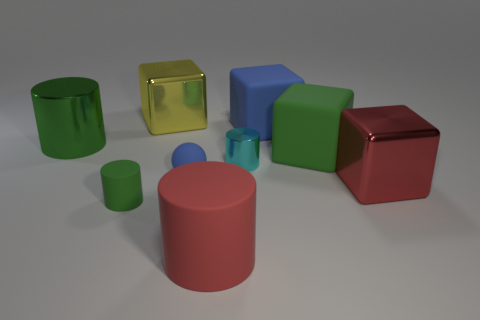Is there anything else that is the same color as the small rubber cylinder?
Your answer should be compact. Yes. What is the shape of the small cyan thing behind the tiny blue matte sphere?
Ensure brevity in your answer.  Cylinder. Is the color of the large matte cylinder the same as the big metallic cube that is to the left of the cyan cylinder?
Offer a very short reply. No. Is the number of metallic objects left of the large blue thing the same as the number of large yellow things that are right of the yellow metal cube?
Ensure brevity in your answer.  No. How many other things are there of the same size as the yellow metallic block?
Offer a terse response. 5. The green metal cylinder has what size?
Ensure brevity in your answer.  Large. Is the small ball made of the same material as the large red thing that is left of the big blue object?
Make the answer very short. Yes. Is there a red metallic thing that has the same shape as the big red rubber object?
Offer a very short reply. No. There is a blue ball that is the same size as the cyan thing; what material is it?
Your answer should be very brief. Rubber. What is the size of the block to the left of the blue matte sphere?
Offer a terse response. Large. 